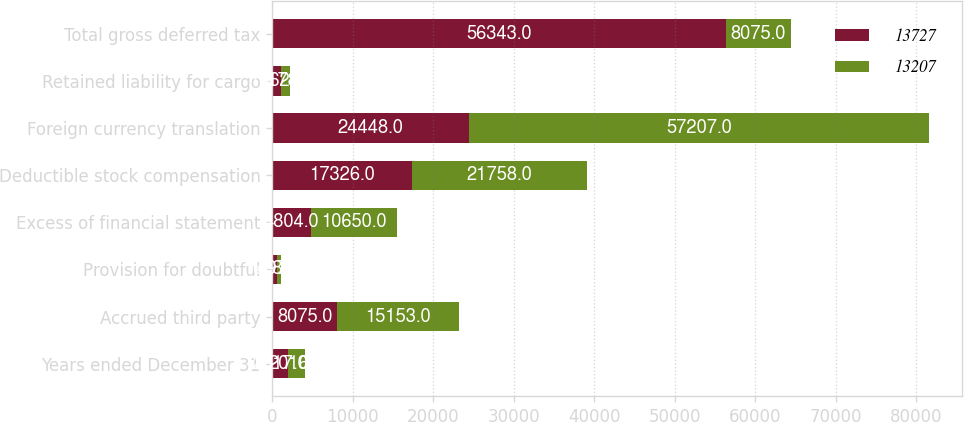<chart> <loc_0><loc_0><loc_500><loc_500><stacked_bar_chart><ecel><fcel>Years ended December 31<fcel>Accrued third party<fcel>Provision for doubtful<fcel>Excess of financial statement<fcel>Deductible stock compensation<fcel>Foreign currency translation<fcel>Retained liability for cargo<fcel>Total gross deferred tax<nl><fcel>13727<fcel>2017<fcel>8075<fcel>628<fcel>4804<fcel>17326<fcel>24448<fcel>1062<fcel>56343<nl><fcel>13207<fcel>2016<fcel>15153<fcel>497<fcel>10650<fcel>21758<fcel>57207<fcel>1178<fcel>8075<nl></chart> 